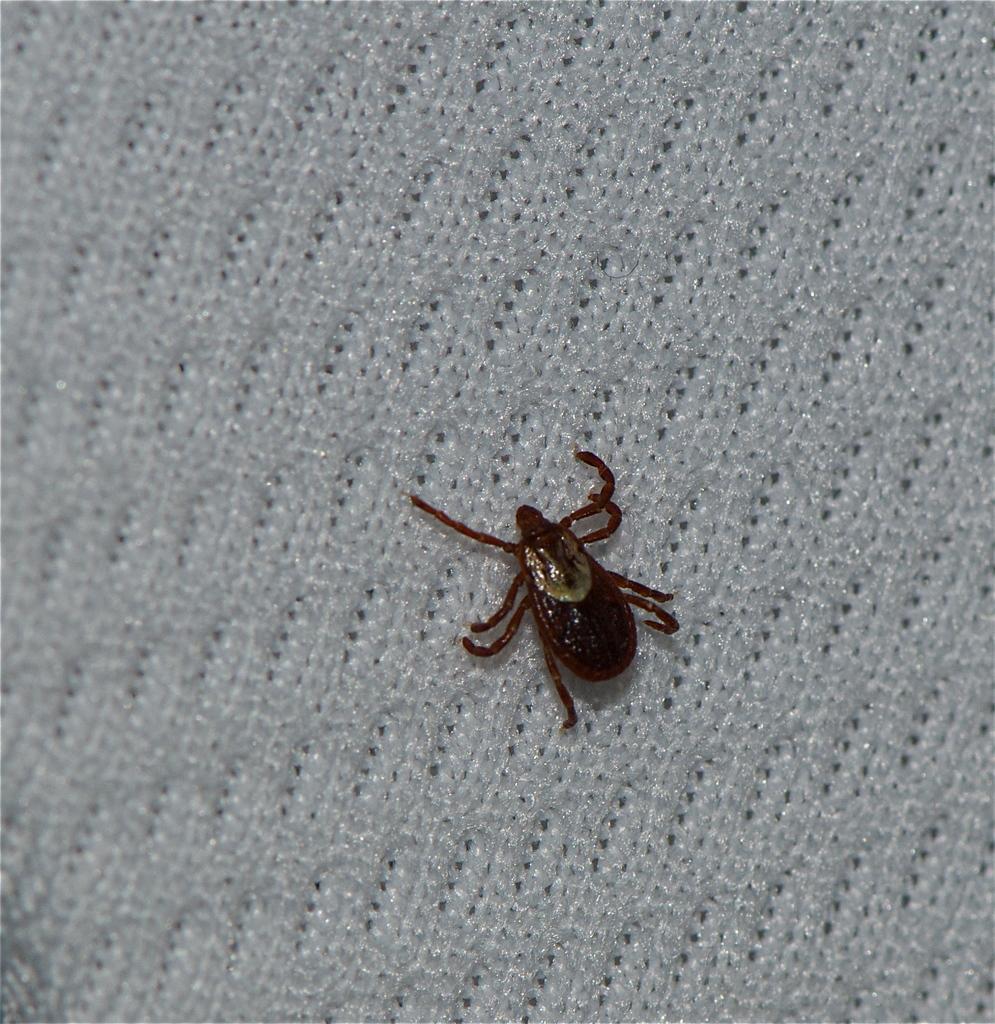Can you describe this image briefly? In this picture we can see a Dermacentor here, at the bottom there is a cloth. 